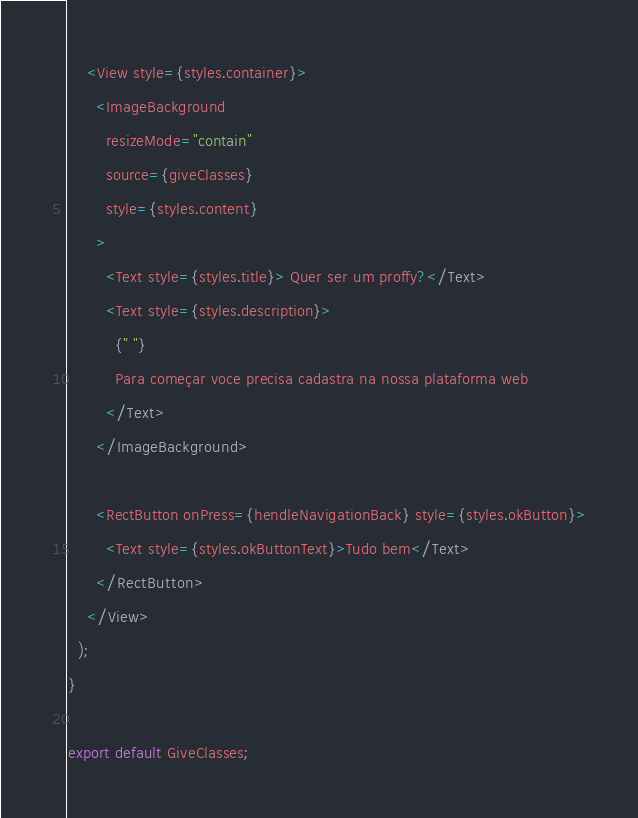Convert code to text. <code><loc_0><loc_0><loc_500><loc_500><_TypeScript_>    <View style={styles.container}>
      <ImageBackground
        resizeMode="contain"
        source={giveClasses}
        style={styles.content}
      >
        <Text style={styles.title}> Quer ser um proffy?</Text>
        <Text style={styles.description}>
          {" "}
          Para começar voce precisa cadastra na nossa plataforma web
        </Text>
      </ImageBackground>

      <RectButton onPress={hendleNavigationBack} style={styles.okButton}>
        <Text style={styles.okButtonText}>Tudo bem</Text>
      </RectButton>
    </View>
  );
}

export default GiveClasses;
</code> 